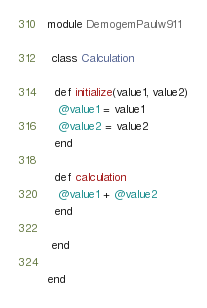Convert code to text. <code><loc_0><loc_0><loc_500><loc_500><_Ruby_>module DemogemPaulw911

 class Calculation

  def initialize(value1, value2)
   @value1 = value1
   @value2 = value2
  end

  def calculation
   @value1 + @value2
  end

 end

end
</code> 